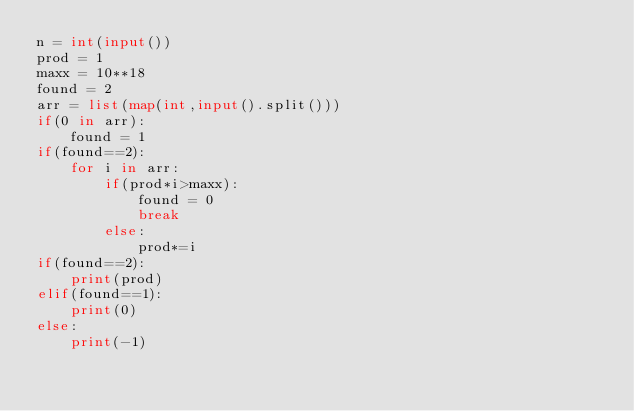<code> <loc_0><loc_0><loc_500><loc_500><_Python_>n = int(input())
prod = 1
maxx = 10**18
found = 2
arr = list(map(int,input().split()))
if(0 in arr):
    found = 1
if(found==2):
    for i in arr:
        if(prod*i>maxx):
            found = 0
            break
        else:
            prod*=i
if(found==2):
    print(prod)
elif(found==1):
    print(0)
else:
    print(-1)

    
    </code> 